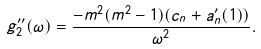<formula> <loc_0><loc_0><loc_500><loc_500>g _ { 2 } ^ { \prime \prime } ( \omega ) = \frac { - m ^ { 2 } ( m ^ { 2 } - 1 ) ( c _ { n } + a _ { n } ^ { \prime } ( 1 ) ) } { \omega ^ { 2 } } .</formula> 